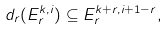Convert formula to latex. <formula><loc_0><loc_0><loc_500><loc_500>d _ { r } ( E _ { r } ^ { k , i } ) \subseteq E _ { r } ^ { k + r , i + 1 - r } ,</formula> 